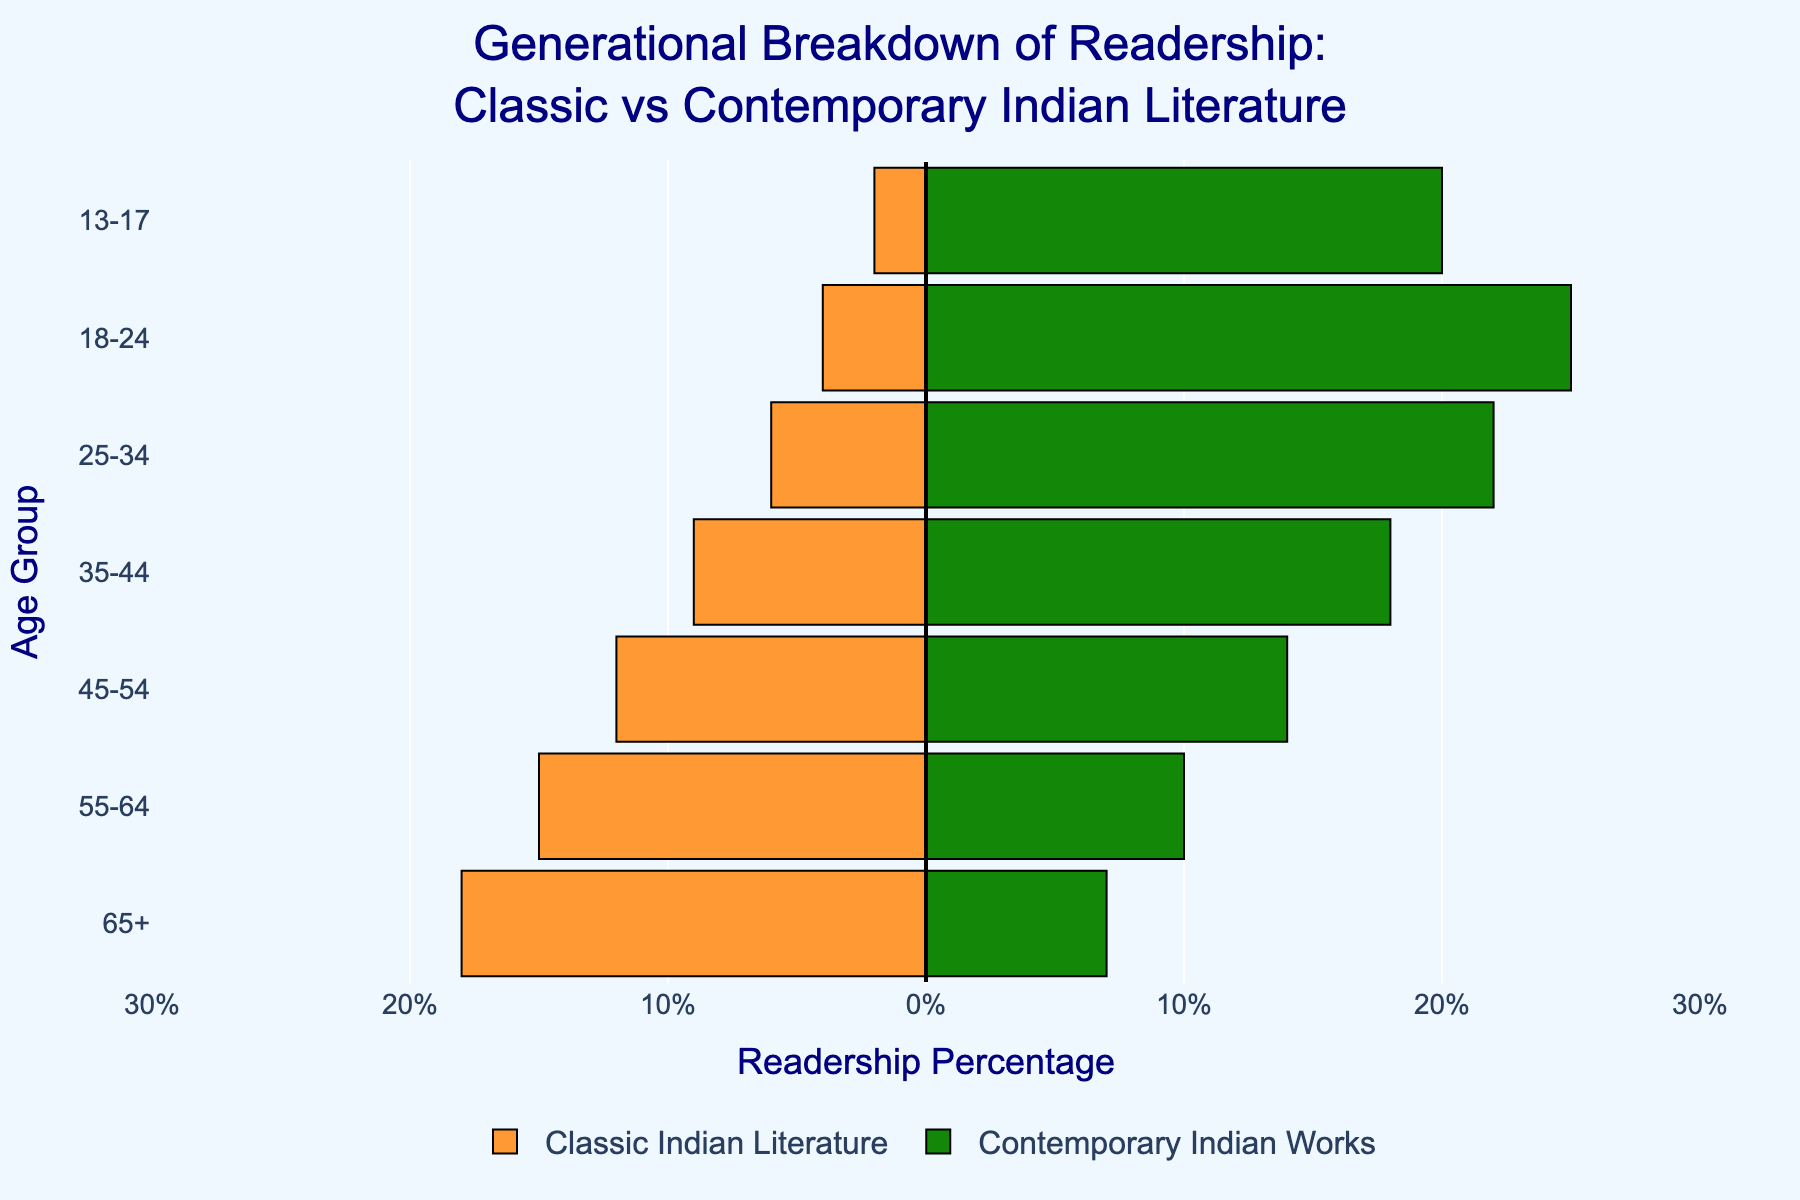What's the dominant readership age group for classic Indian literature? To determine this, look at the lengths of the bars for Classic Indian Literature on the left side of the pyramid. The bar with the largest negative value indicates the age group most involved with classic literature. The 65+ age group is the longest bar.
Answer: 65+ Which age group reads contemporary Indian works the most? Observe the lengths of the bars for Contemporary Indian Works on the right side of the chart. The bar with the largest positive value identifies the age group with the highest readership. The 18-24 age group has the longest bar.
Answer: 18-24 What is the total readership percentage of classic Indian literature in the age groups 55 and older? Calculate the sum of the readership percentages for the age groups 55-64 and 65+. Add the values: 15 (55-64) + 18 (65+).
Answer: 33% Which age group shows the least interest in classic Indian literature? Look at the left side of the pyramid (Classic Indian Literature) for the bar with the smallest negative value. The 13-17 age group has the shortest bar.
Answer: 13-17 How does the readership of contemporary Indian works compare between the 25-34 and the 45-54 age groups? Compare the lengths of the bars for Contemporary Indian Works in these two age groups. The 25-34 age group has a bar length of 22, while the 45-54 age group has a bar length of 14. Therefore, the 25-34 age group has a higher readership.
Answer: 25-34 age group What’s the difference in readership percentage between classic and contemporary works for the 35-44 age group? Find the lengths of the bars for Classic Indian Literature (-9) and Contemporary Indian Works (18) for this age group. The difference is the absolute value of -9 - 18.
Answer: 27% Which age group has a balanced readership between classic and contemporary Indian works? Look for age groups where the bars are of similar length on both sides. The 45-54 age group has bars that are quite close in length, with 12 for classics and 14 for contemporary.
Answer: 45-54 Is there a significant change in readership from classic to contemporary between the younger (13-24) and older (55+) age groups? Compare the bar lengths for these age groups. For 13-17 and 18-24, the total readership for contemporary is 20 + 25 = 45, and for classics, it is 2 + 4 = 6. For 55-64 and 65+, the total readership for contemporary is 10 + 7 = 17, and for classics, it is 15 + 18 = 33. There is a significant change with younger favoring contemporary and older favoring classics.
Answer: Yes What is the average readership percentage for contemporary Indian works across all age groups? Sum the percentages for contemporary works across all age groups (7 + 10 + 14 + 18 + 22 + 25 + 20 = 116). There are 7 age groups, calculate the average by dividing the total by the number of groups (116/7).
Answer: ~16.6% 